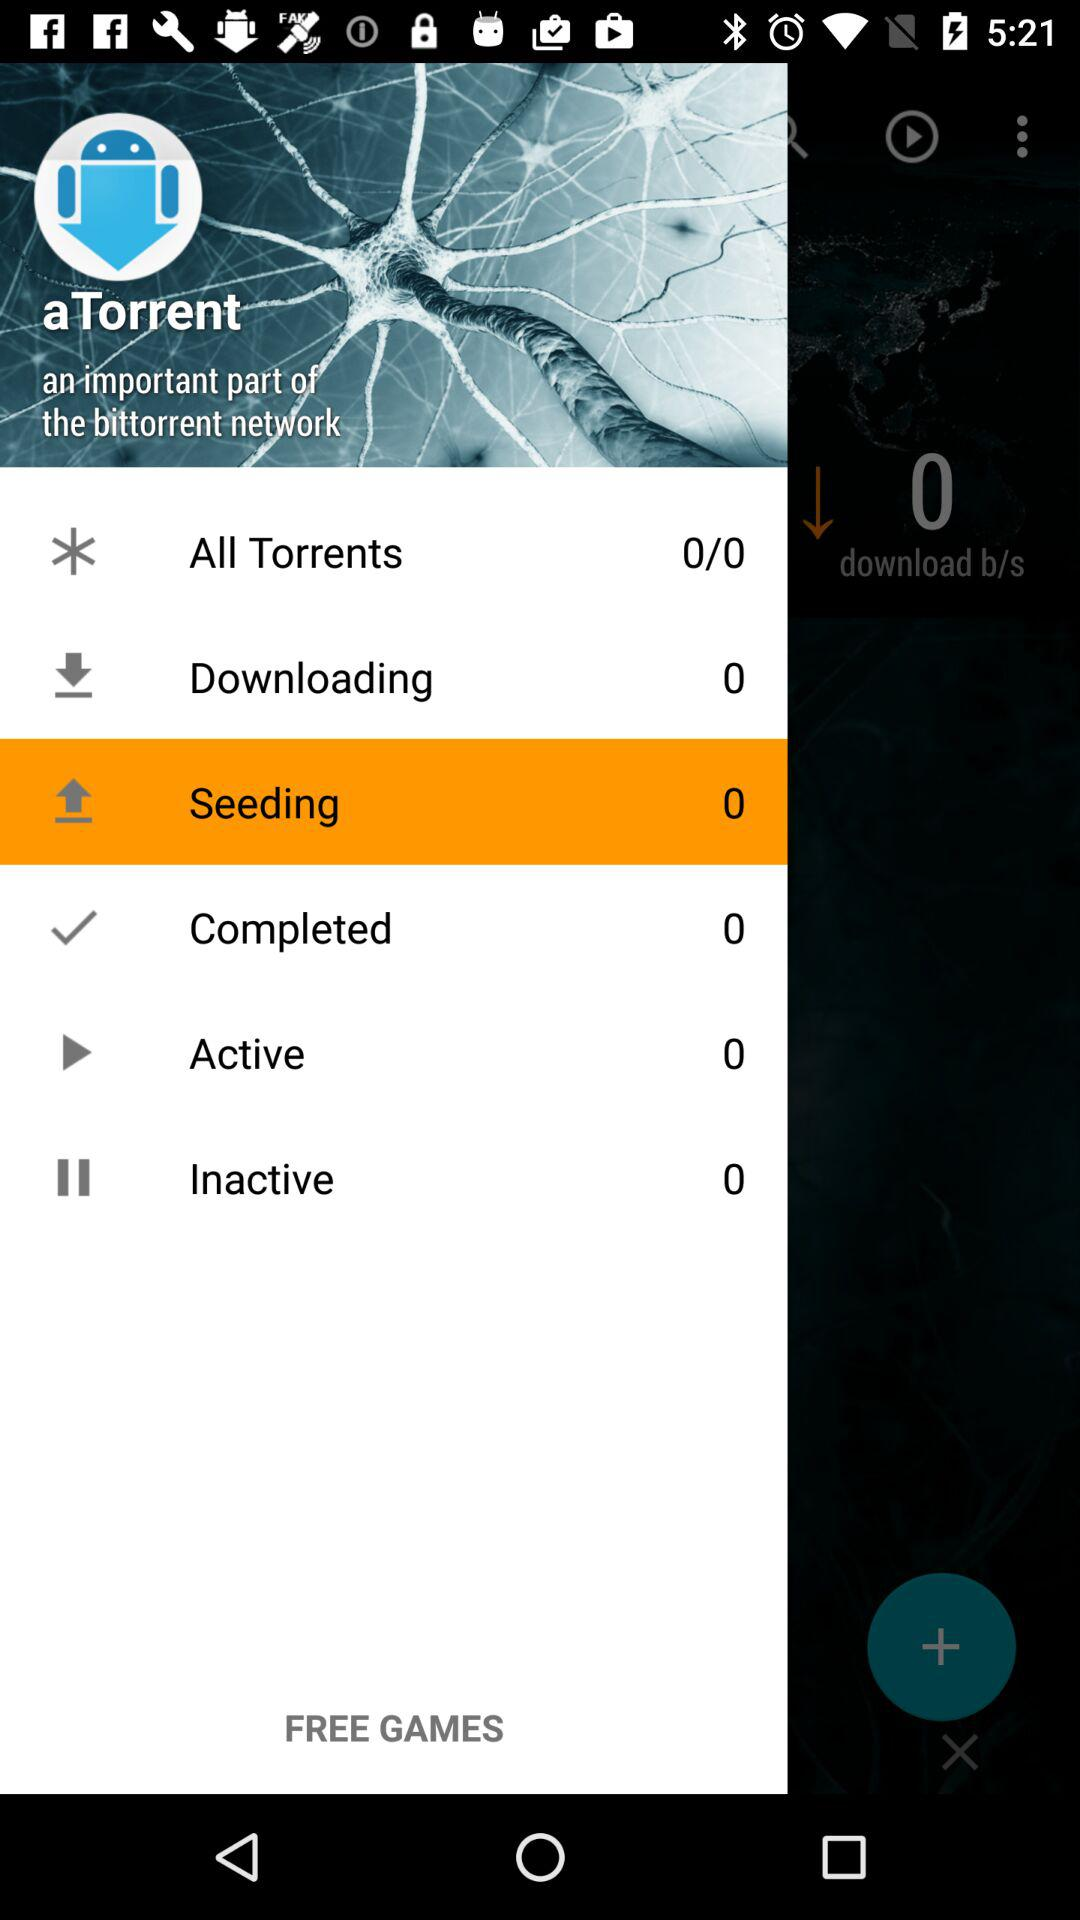How many numbers are in "Inactive"? There are 0 numbers in "Inactive". 